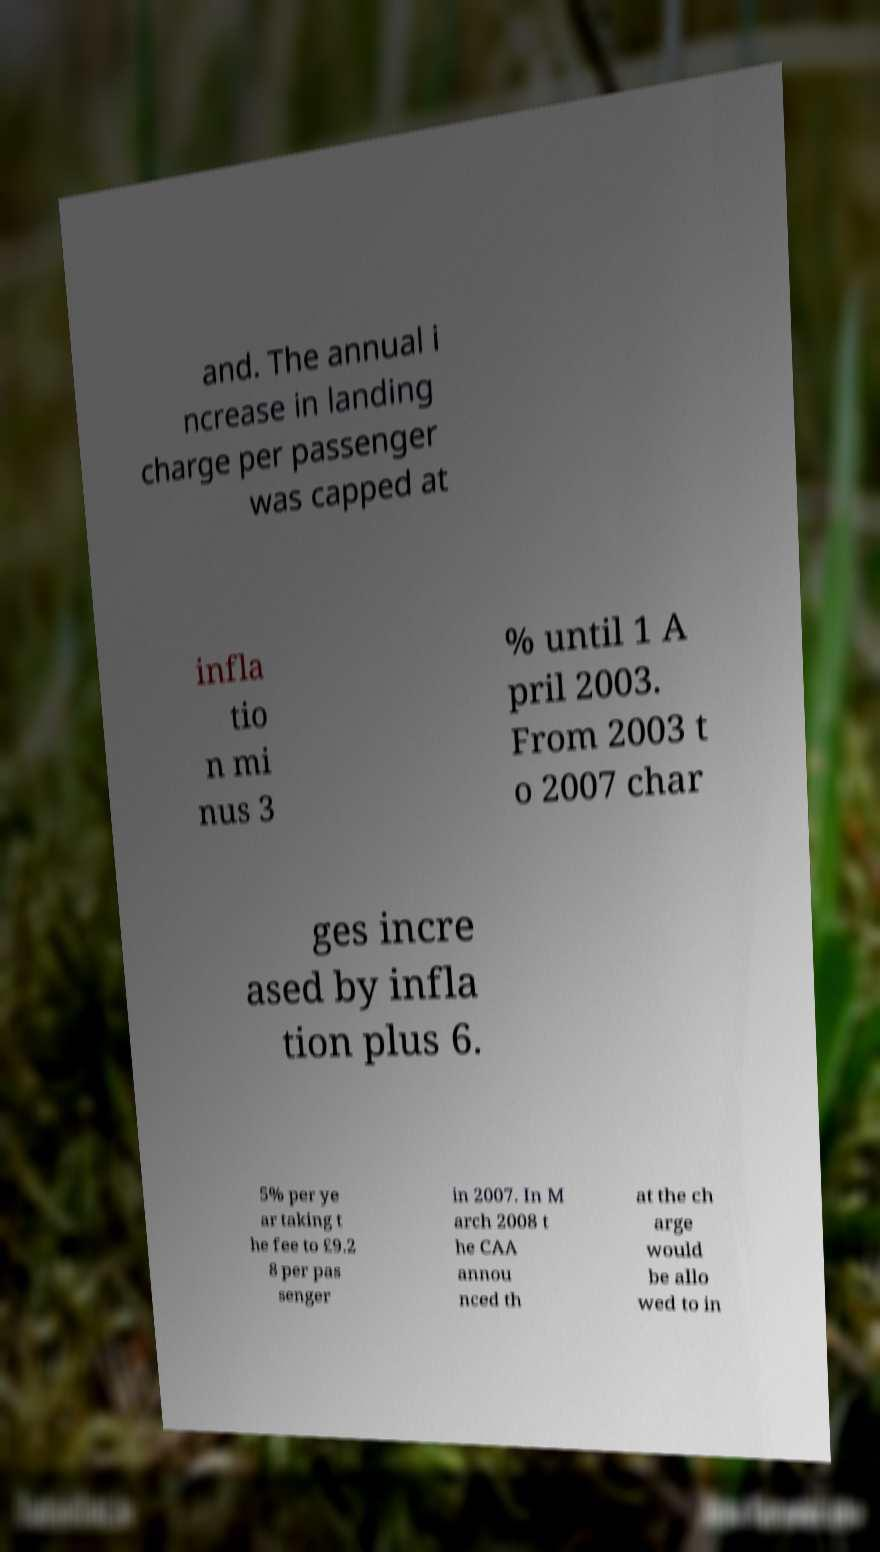Please read and relay the text visible in this image. What does it say? and. The annual i ncrease in landing charge per passenger was capped at infla tio n mi nus 3 % until 1 A pril 2003. From 2003 t o 2007 char ges incre ased by infla tion plus 6. 5% per ye ar taking t he fee to £9.2 8 per pas senger in 2007. In M arch 2008 t he CAA annou nced th at the ch arge would be allo wed to in 